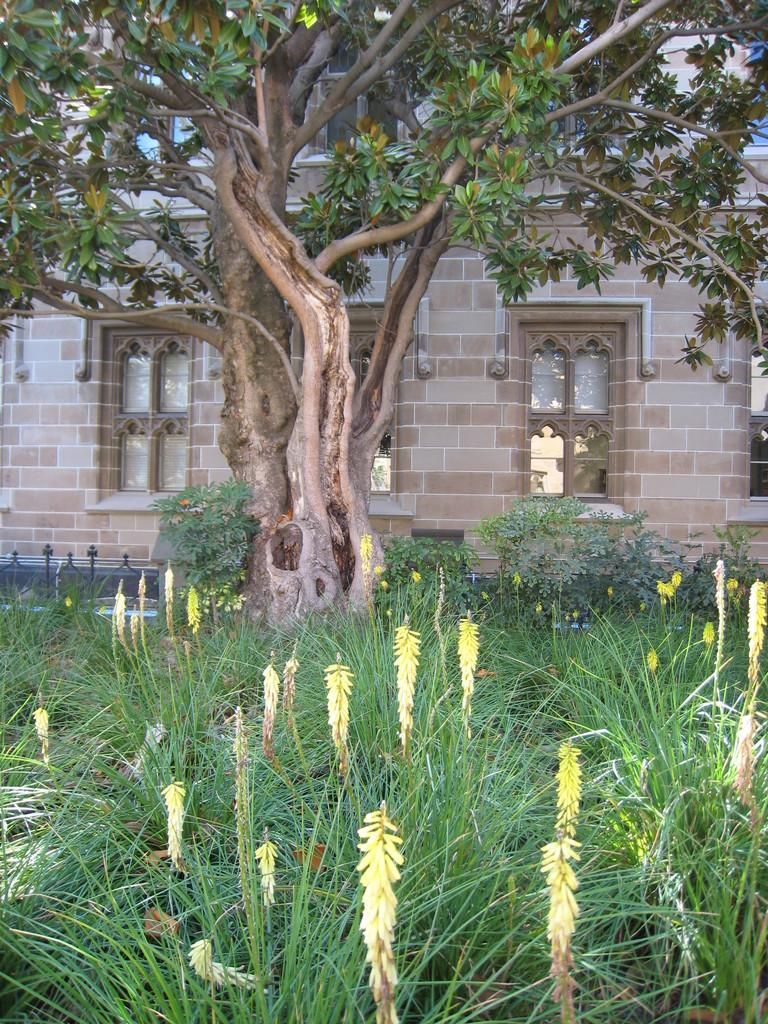What celestial bodies are shown at the bottom of the image? There are planets depicted at the bottom of the image. What natural element is in the middle of the image? There is a tree in the middle of the image. What type of structure can be seen in the background of the image? There is a house visible in the background of the image. Where is the hole located in the image? There is no hole present in the image. What type of place is depicted in the image? The image does not depict a specific place; it features planets, a tree, and a house. 